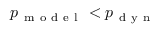<formula> <loc_0><loc_0><loc_500><loc_500>p _ { m o d e l } < p _ { d y n }</formula> 